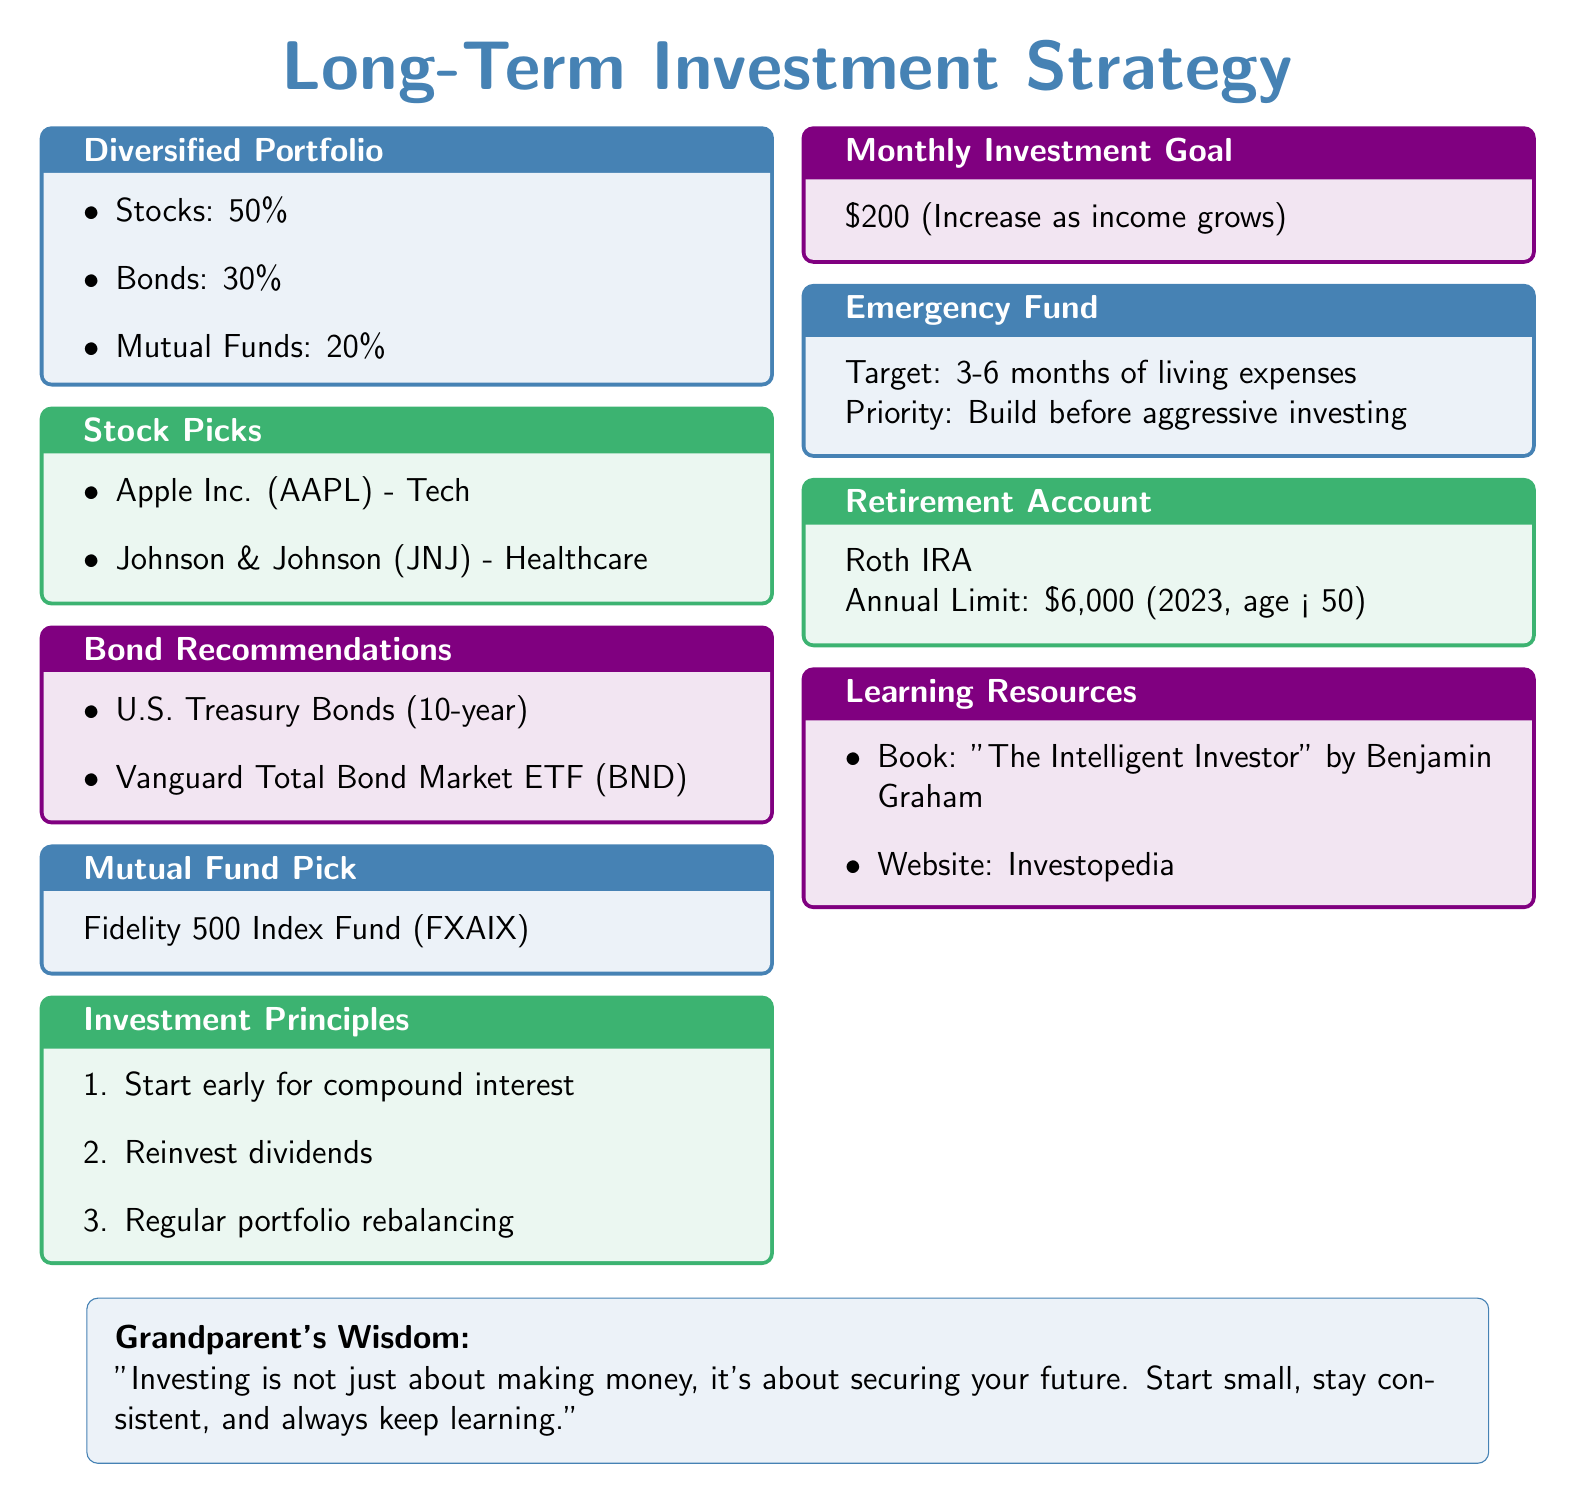What is the percentage allocation for stocks? The document specifies that 50% of the diversified portfolio is allocated to stocks.
Answer: 50% How much should you invest monthly to meet your goal? The document states that the monthly investment goal is $200.
Answer: $200 What type of bond is recommended? Among the bonds mentioned, U.S. Treasury Bonds (10-year) is one of the recommendations.
Answer: U.S. Treasury Bonds (10-year) What is the annual limit for a Roth IRA? The document indicates that the annual limit for a Roth IRA is $6,000 for individuals under 50.
Answer: $6,000 What is the recommended mutual fund? The Fidelity 500 Index Fund (FXAIX) is listed as the mutual fund pick.
Answer: Fidelity 500 Index Fund (FXAIX) How many months of living expenses should an emergency fund cover? The document recommends building an emergency fund to cover 3-6 months of living expenses.
Answer: 3-6 months Which book is recommended for learning about investing? The book "The Intelligent Investor" by Benjamin Graham is mentioned as a learning resource.
Answer: "The Intelligent Investor" by Benjamin Graham What is one investment principle listed in the document? One of the investment principles mentioned is to start early for compound interest.
Answer: Start early for compound interest What percentage of the portfolio is allocated to mutual funds? The document specifies that 20% of the diversified portfolio is allocated to mutual funds.
Answer: 20% 